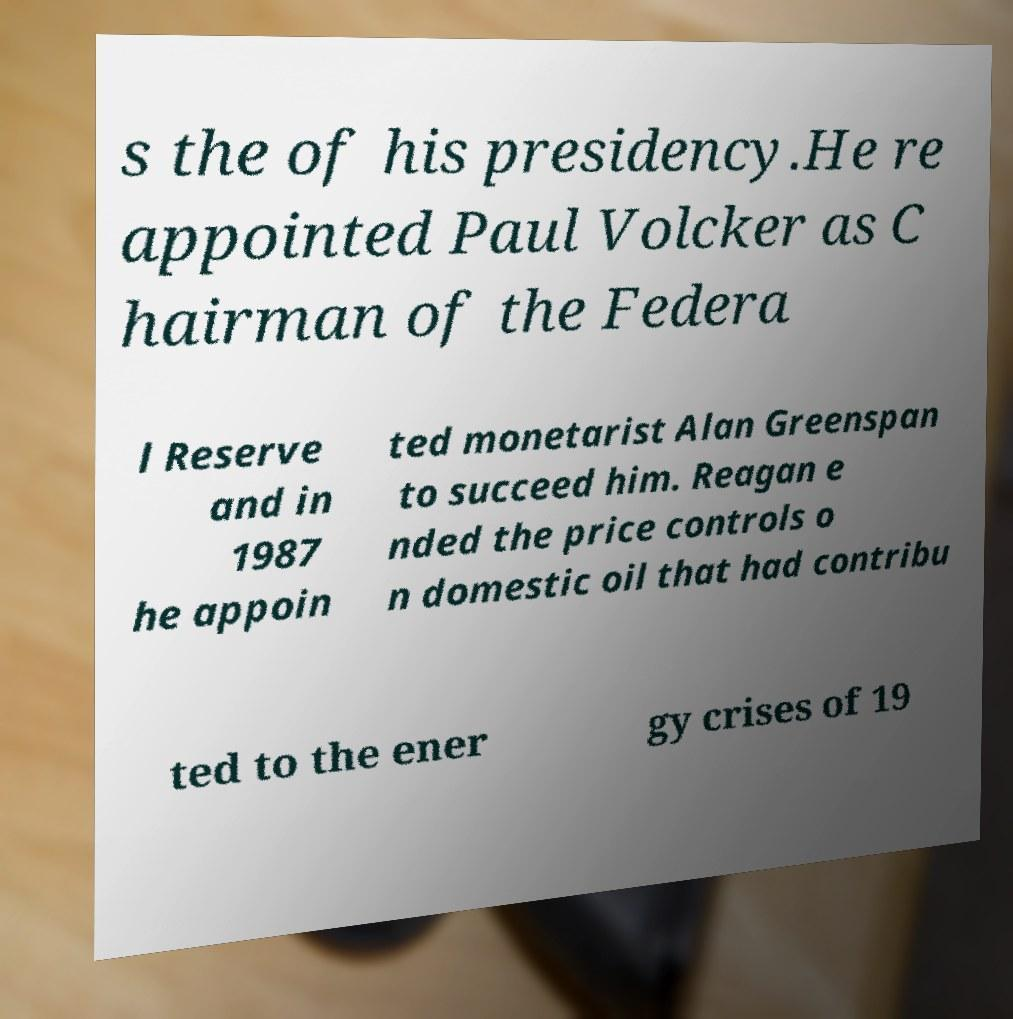Can you read and provide the text displayed in the image?This photo seems to have some interesting text. Can you extract and type it out for me? s the of his presidency.He re appointed Paul Volcker as C hairman of the Federa l Reserve and in 1987 he appoin ted monetarist Alan Greenspan to succeed him. Reagan e nded the price controls o n domestic oil that had contribu ted to the ener gy crises of 19 